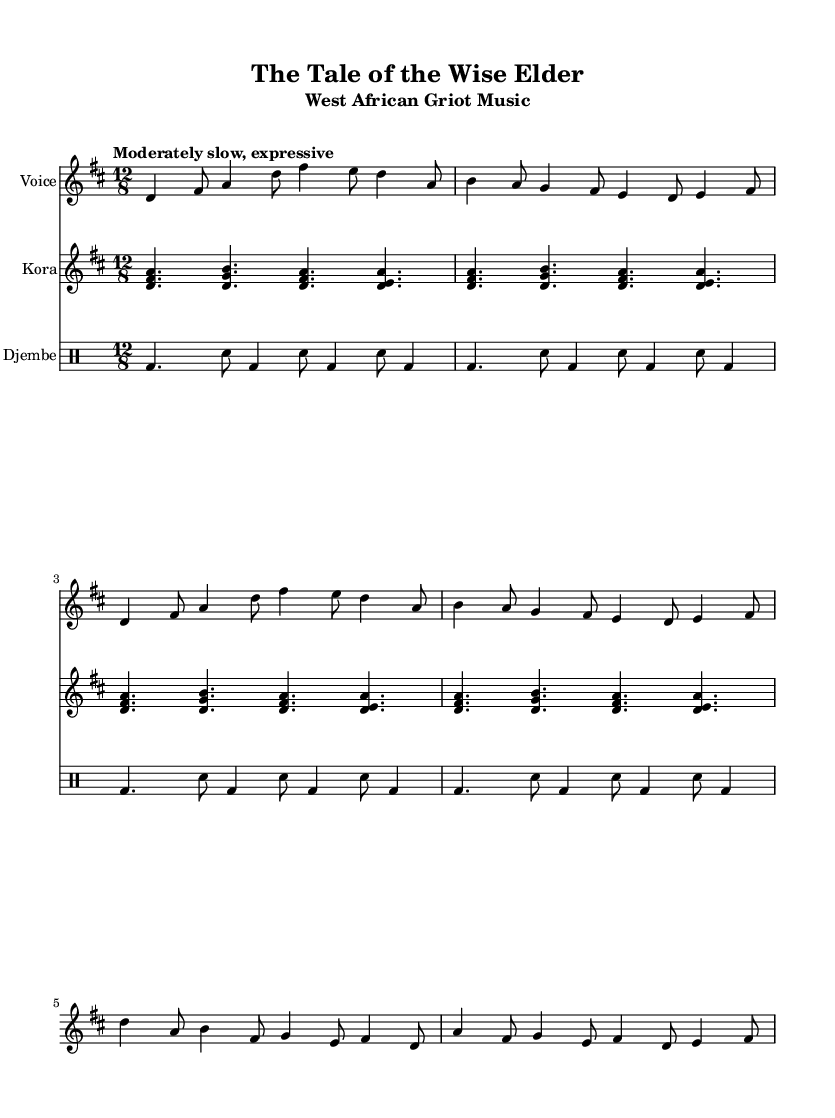What is the key signature of this music? The key signature is indicated at the beginning of the staff. There are two sharps present, namely F# and C#. Therefore, the key signature corresponds to D major.
Answer: D major What is the time signature of this music? The time signature is located at the beginning of the score. It shows 12/8, which means there are 12 beats in a measure and the eighth note gets one beat.
Answer: 12/8 What is the tempo marking of this music? The tempo marking is indicated at the beginning of the score. "Moderately slow, expressive" informs performers of the desired speed and expressive quality.
Answer: Moderately slow, expressive How many measures are there in the voice part? By counting the vertical lines (bar lines) in the voice part, we can identify the measures. The voice part has a total of 6 measures.
Answer: 6 What instrument plays the arpeggiated pattern? The arpeggiated pattern is specified under the kora part. The staff is labeled "Kora," indicating that this instrument plays the arpeggiated pattern displayed.
Answer: Kora What rhythmic figure is repeated in the djembe part? By observing the djembe staff, we note the use of repeated patterns consisting of bass and snare drum beats. The pattern forms a distinctive rhythmic figure across the repeated sections.
Answer: bd4. sn8 